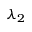Convert formula to latex. <formula><loc_0><loc_0><loc_500><loc_500>\lambda _ { 2 }</formula> 